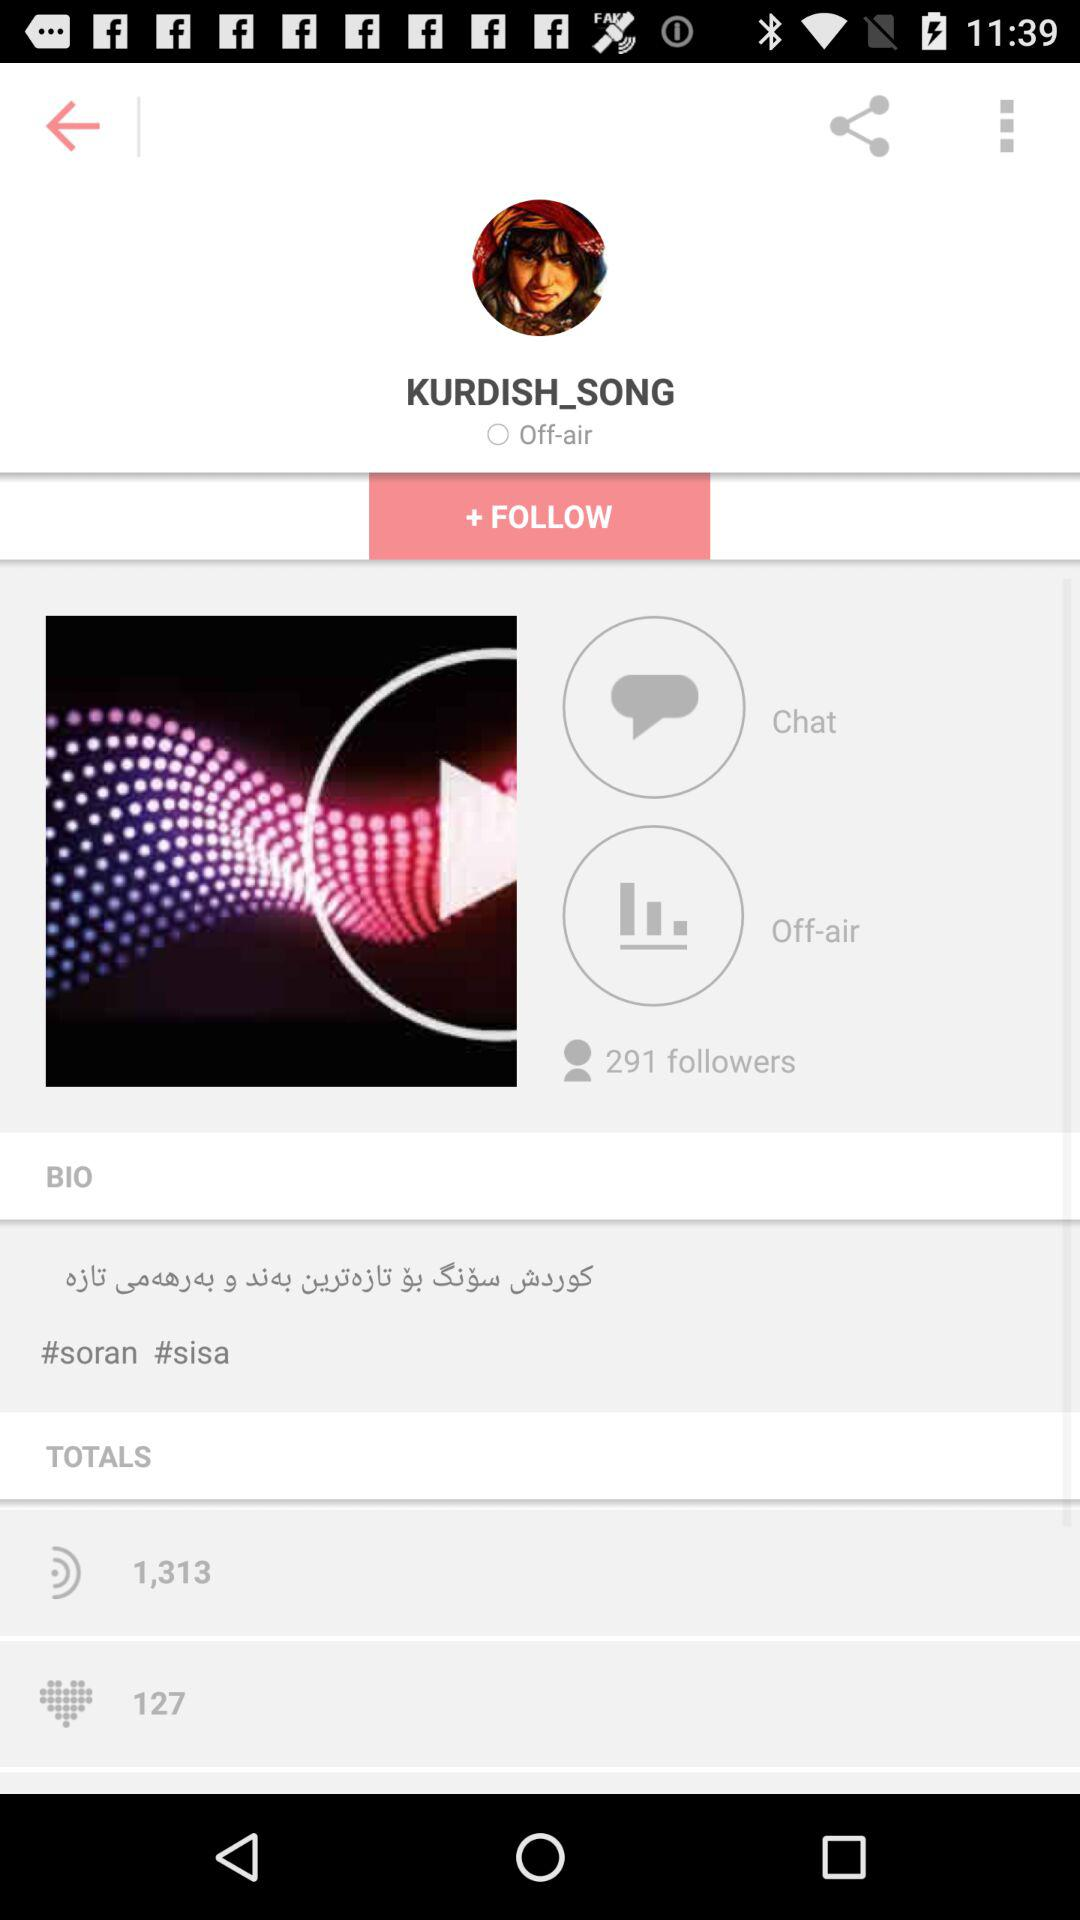Which hashtag is use on this song?
When the provided information is insufficient, respond with <no answer>. <no answer> 